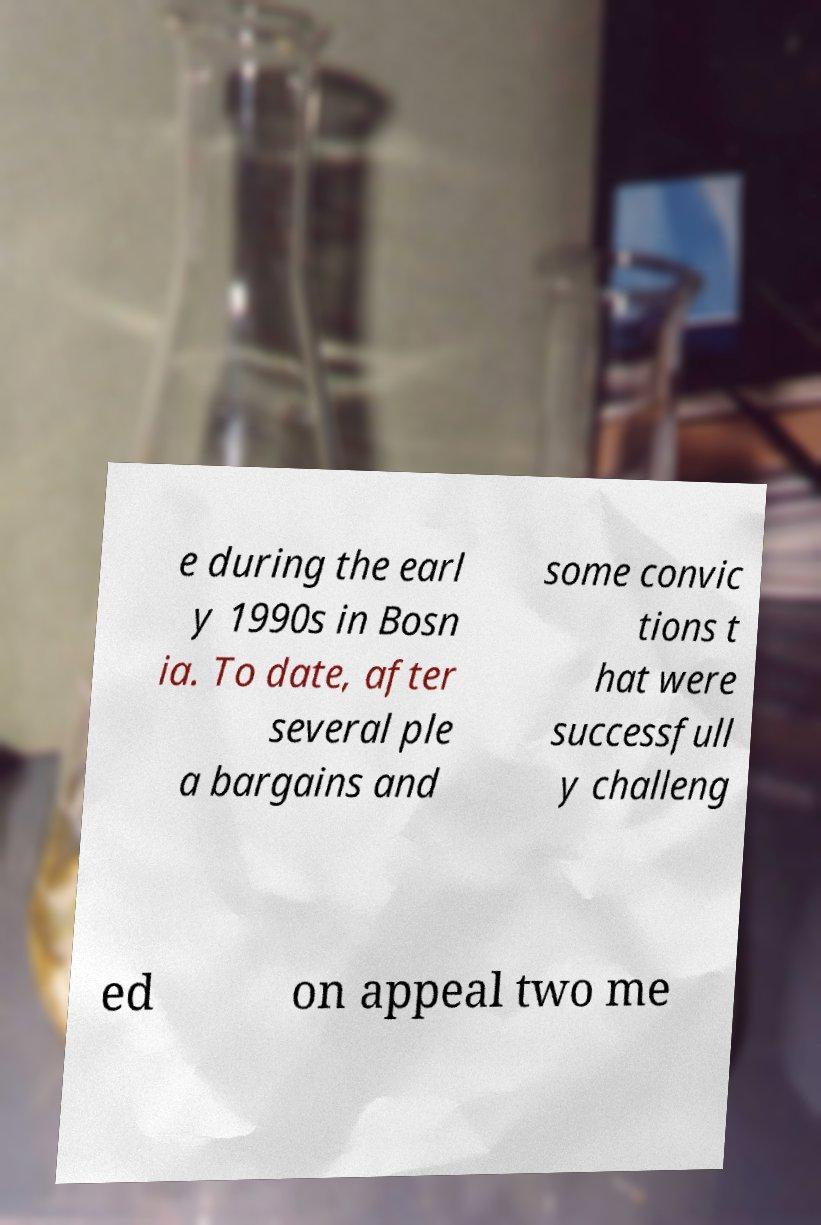Could you extract and type out the text from this image? e during the earl y 1990s in Bosn ia. To date, after several ple a bargains and some convic tions t hat were successfull y challeng ed on appeal two me 